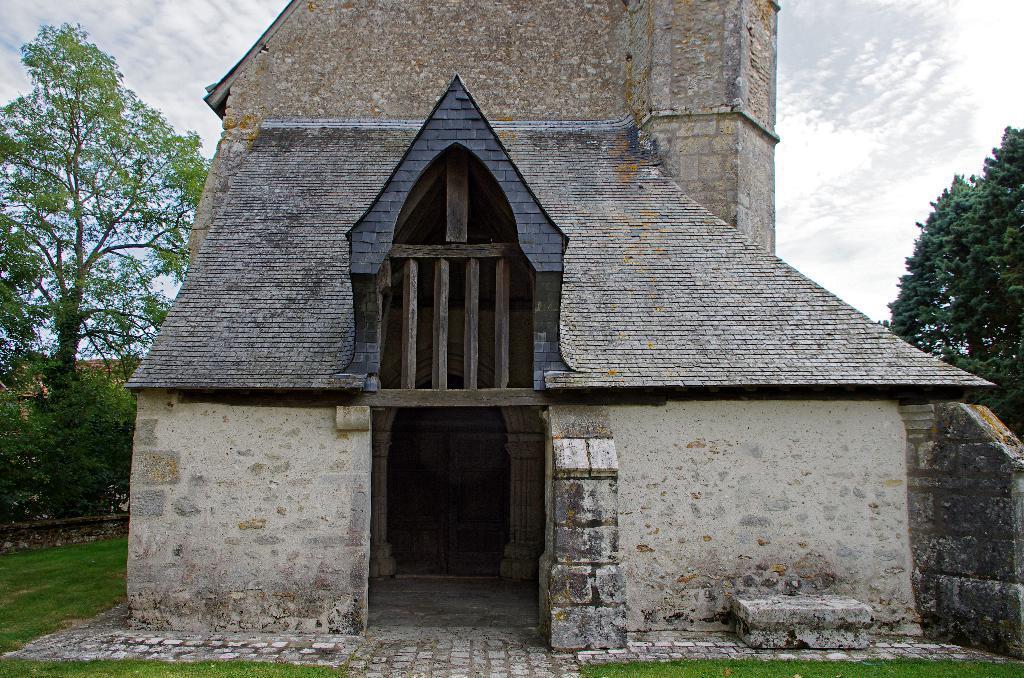Please provide a concise description of this image. As we can see in the image there is a building, grass, plants and trees. At the top there is sky. 